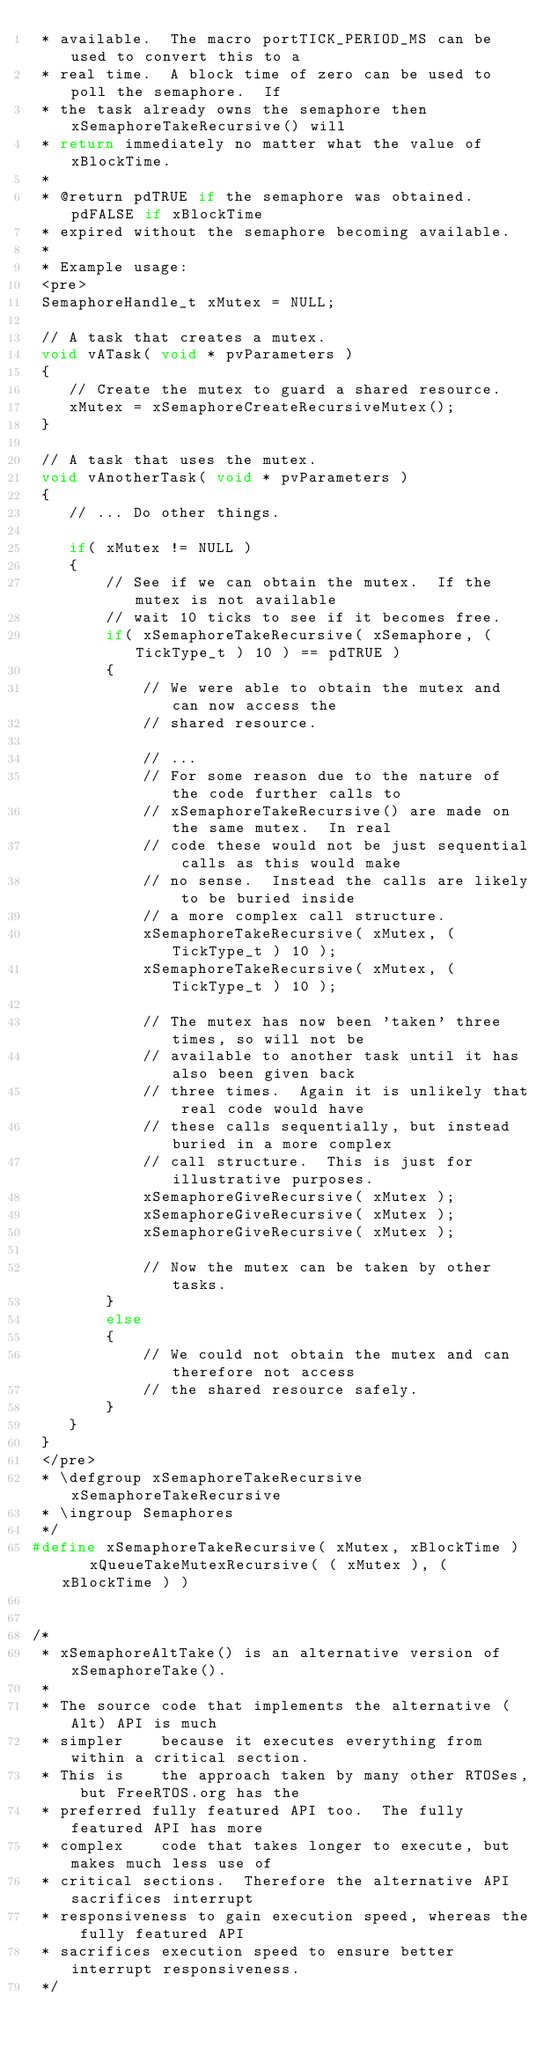Convert code to text. <code><loc_0><loc_0><loc_500><loc_500><_C_> * available.  The macro portTICK_PERIOD_MS can be used to convert this to a
 * real time.  A block time of zero can be used to poll the semaphore.  If
 * the task already owns the semaphore then xSemaphoreTakeRecursive() will
 * return immediately no matter what the value of xBlockTime.
 *
 * @return pdTRUE if the semaphore was obtained.  pdFALSE if xBlockTime
 * expired without the semaphore becoming available.
 *
 * Example usage:
 <pre>
 SemaphoreHandle_t xMutex = NULL;

 // A task that creates a mutex.
 void vATask( void * pvParameters )
 {
    // Create the mutex to guard a shared resource.
    xMutex = xSemaphoreCreateRecursiveMutex();
 }

 // A task that uses the mutex.
 void vAnotherTask( void * pvParameters )
 {
    // ... Do other things.

    if( xMutex != NULL )
    {
        // See if we can obtain the mutex.  If the mutex is not available
        // wait 10 ticks to see if it becomes free.
        if( xSemaphoreTakeRecursive( xSemaphore, ( TickType_t ) 10 ) == pdTRUE )
        {
            // We were able to obtain the mutex and can now access the
            // shared resource.

            // ...
            // For some reason due to the nature of the code further calls to
            // xSemaphoreTakeRecursive() are made on the same mutex.  In real
            // code these would not be just sequential calls as this would make
            // no sense.  Instead the calls are likely to be buried inside
            // a more complex call structure.
            xSemaphoreTakeRecursive( xMutex, ( TickType_t ) 10 );
            xSemaphoreTakeRecursive( xMutex, ( TickType_t ) 10 );

            // The mutex has now been 'taken' three times, so will not be
            // available to another task until it has also been given back
            // three times.  Again it is unlikely that real code would have
            // these calls sequentially, but instead buried in a more complex
            // call structure.  This is just for illustrative purposes.
            xSemaphoreGiveRecursive( xMutex );
            xSemaphoreGiveRecursive( xMutex );
            xSemaphoreGiveRecursive( xMutex );

            // Now the mutex can be taken by other tasks.
        }
        else
        {
            // We could not obtain the mutex and can therefore not access
            // the shared resource safely.
        }
    }
 }
 </pre>
 * \defgroup xSemaphoreTakeRecursive xSemaphoreTakeRecursive
 * \ingroup Semaphores
 */
#define xSemaphoreTakeRecursive( xMutex, xBlockTime )    xQueueTakeMutexRecursive( ( xMutex ), ( xBlockTime ) )


/*
 * xSemaphoreAltTake() is an alternative version of xSemaphoreTake().
 *
 * The source code that implements the alternative (Alt) API is much
 * simpler    because it executes everything from within a critical section.
 * This is    the approach taken by many other RTOSes, but FreeRTOS.org has the
 * preferred fully featured API too.  The fully featured API has more
 * complex    code that takes longer to execute, but makes much less use of
 * critical sections.  Therefore the alternative API sacrifices interrupt
 * responsiveness to gain execution speed, whereas the fully featured API
 * sacrifices execution speed to ensure better interrupt responsiveness.
 */</code> 